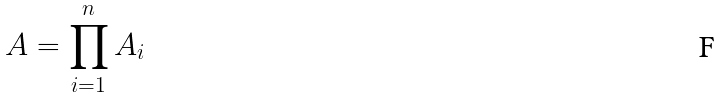Convert formula to latex. <formula><loc_0><loc_0><loc_500><loc_500>A = \prod _ { i = 1 } ^ { n } A _ { i }</formula> 